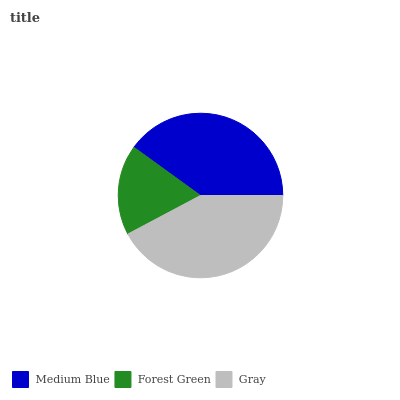Is Forest Green the minimum?
Answer yes or no. Yes. Is Gray the maximum?
Answer yes or no. Yes. Is Gray the minimum?
Answer yes or no. No. Is Forest Green the maximum?
Answer yes or no. No. Is Gray greater than Forest Green?
Answer yes or no. Yes. Is Forest Green less than Gray?
Answer yes or no. Yes. Is Forest Green greater than Gray?
Answer yes or no. No. Is Gray less than Forest Green?
Answer yes or no. No. Is Medium Blue the high median?
Answer yes or no. Yes. Is Medium Blue the low median?
Answer yes or no. Yes. Is Gray the high median?
Answer yes or no. No. Is Forest Green the low median?
Answer yes or no. No. 